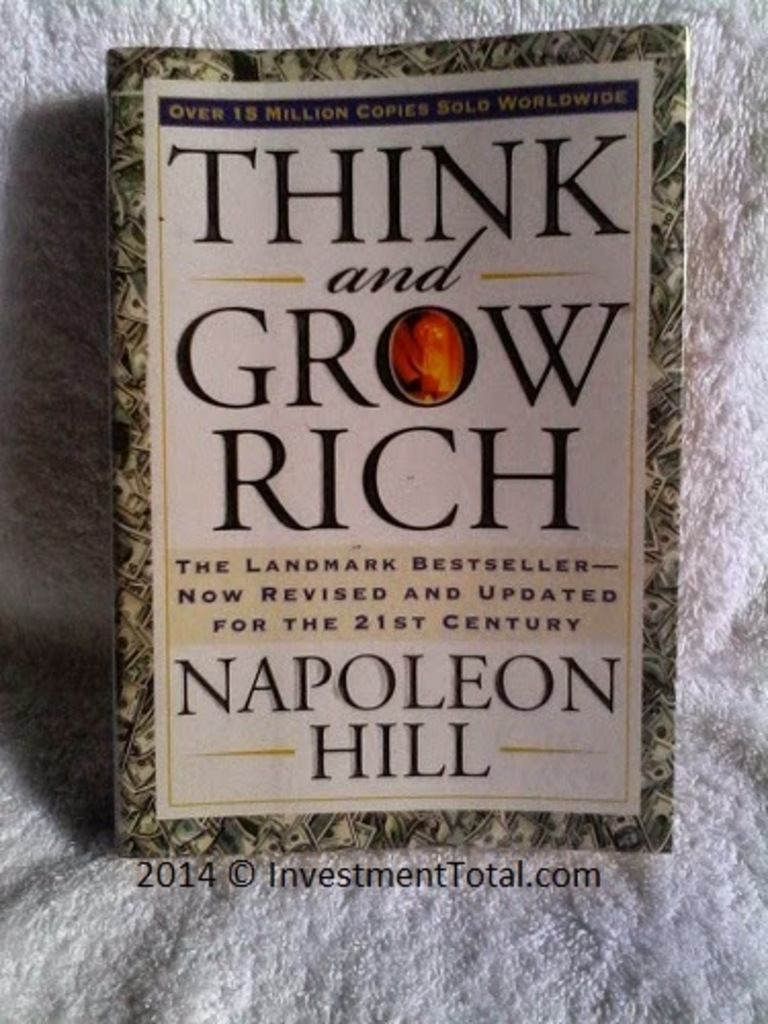Can you explain why the book 'Think and Grow Rich' remains relevant today, as seen from its updated cover for the 21st century? The enduring relevance of 'Think and Grow Rich' is reflected in the updated cover design, which proclaims it as a 'Landmark Bestseller Revised and Updated for the 21st Century.' The principles of personal success, as outlined by Napoleon Hill, are universal and timeless, resonating with new generations of readers seeking to understand and apply the laws of success. The updated edition ensures that contemporary contexts and modern examples are woven into the original teachings, thus maintaining its applicability in today's fast-evolving economic and social landscapes. This continued relevance is further underscored by the robust sales figure, exceeding 15 million copies worldwide, indicating its ongoing impact and significance. 